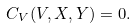<formula> <loc_0><loc_0><loc_500><loc_500>{ C } _ { V } ( V , X , Y ) = 0 .</formula> 